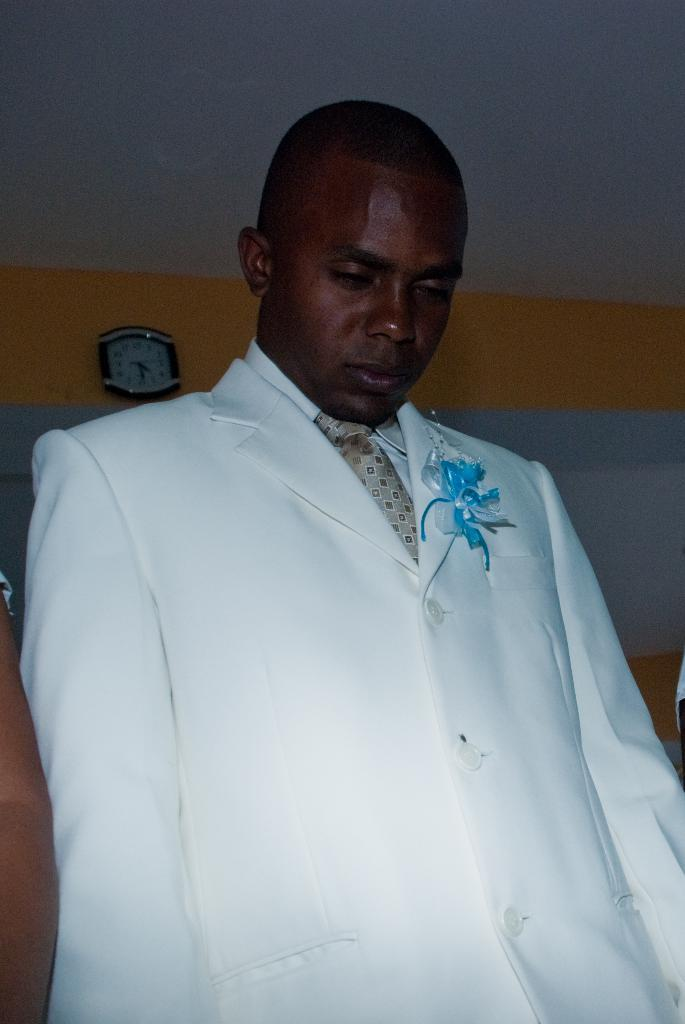Who is present in the image? There is a man in the image. What is the man wearing? The man is wearing a white suit with blue flowers. What is the man doing in the image? The man is standing in the image. What can be seen in the background of the image? There is a yellow and white wall in the background. What object is present on the wall? There is a clock on the wall. What type of scissors can be seen in the image? There are no scissors present in the image. How many stars are visible in the image? There are no stars visible in the image. 